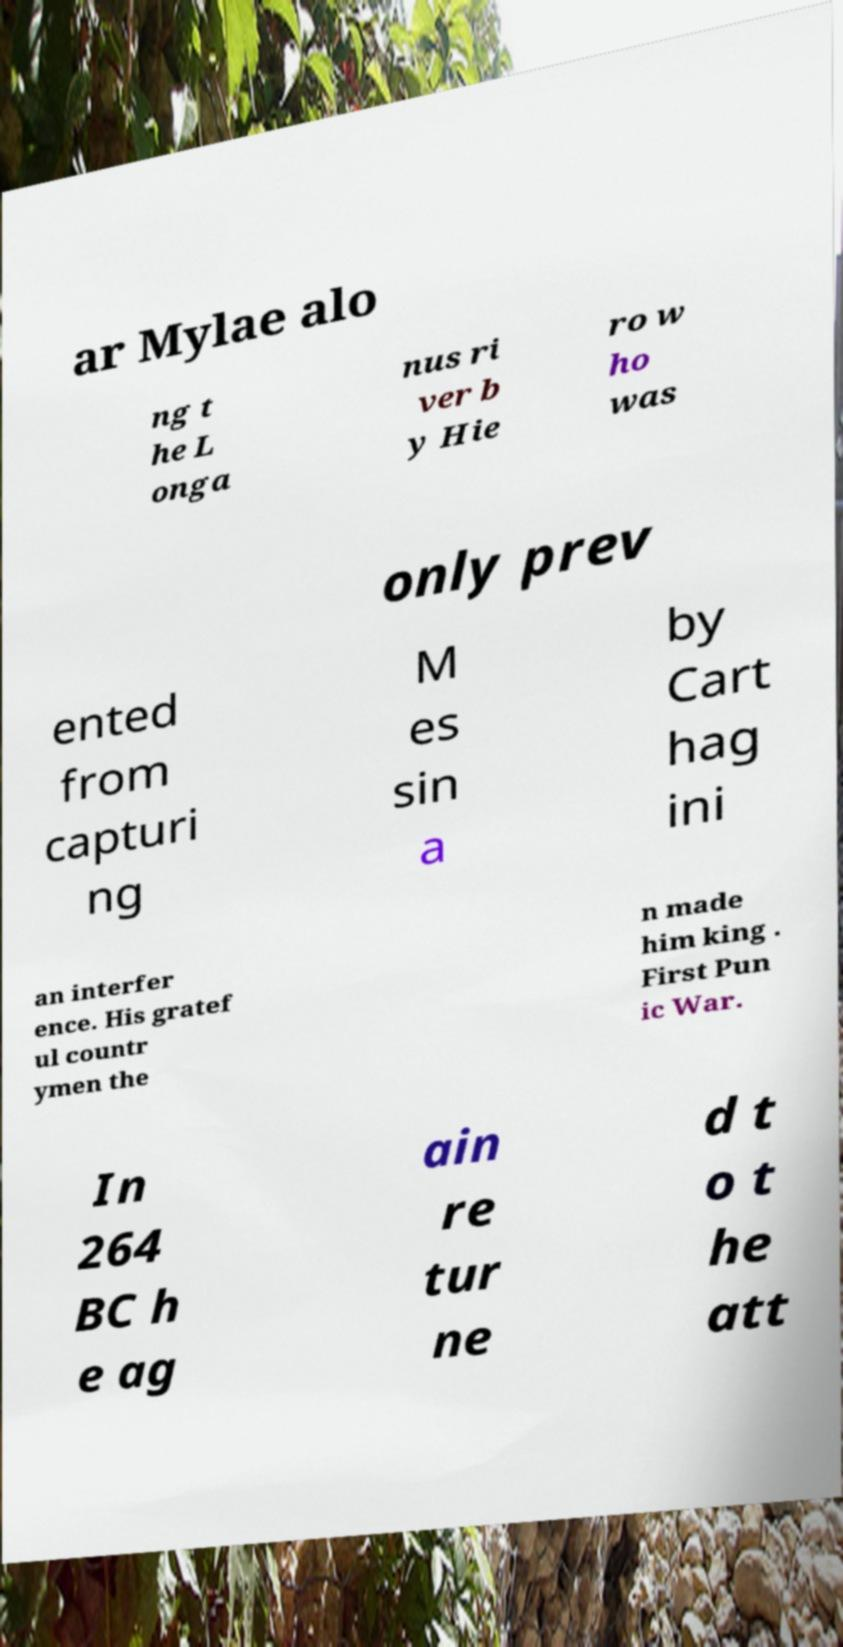For documentation purposes, I need the text within this image transcribed. Could you provide that? ar Mylae alo ng t he L onga nus ri ver b y Hie ro w ho was only prev ented from capturi ng M es sin a by Cart hag ini an interfer ence. His gratef ul countr ymen the n made him king . First Pun ic War. In 264 BC h e ag ain re tur ne d t o t he att 